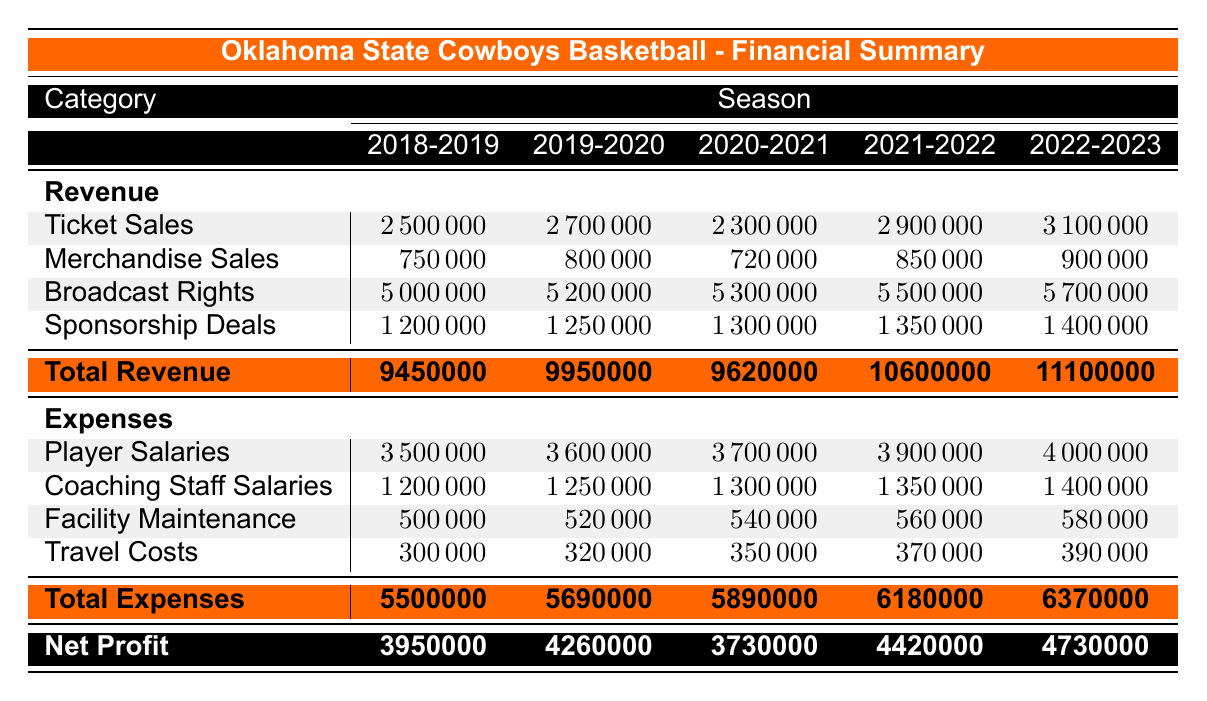What was the highest revenue amount in the 2022-2023 season? The revenue category is divided into four parts: Ticket Sales, Merchandise Sales, Broadcast Rights, and Sponsorship Deals. The Broadcast Rights in the 2022-2023 season show a revenue of 5700000, which is the highest amount compared to other categories for that season.
Answer: 5700000 What is the total revenue for the 2021-2022 season? The total revenue for the 2021-2022 season is already calculated in the table and is stated under the Total Revenue row as 10600000.
Answer: 10600000 Is the net profit for the 2020-2021 season greater than 4000000? The net profit for the 2020-2021 season is listed as 3730000. Since 3730000 is less than 4000000, the answer is no.
Answer: No What was the percentage increase in Ticket Sales from the 2018-2019 season to the 2022-2023 season? The Ticket Sales for 2018-2019 were 2500000 and for 2022-2023 were 3100000. The difference is (3100000 - 2500000 = 600000). To find the percentage increase: (600000 / 2500000) * 100 = 24%.
Answer: 24% What were the total expenses for the Oklahoma State Cowboys in the 2019-2020 season and how do they compare to the 2022-2023 season? The total expenses for 2019-2020 are stated as 5690000, while for 2022-2023, they are 6370000. The comparison shows an increase of (6370000 - 5690000) = 680000, meaning the expenses increased over this period.
Answer: 5690000 (2019-2020), 6370000 (2022-2023) What was the total profit for the 2018-2019 season? The net profit for the 2018-2019 season is found in the table under the Net Profit row as 3950000. This is the total profit for that season.
Answer: 3950000 